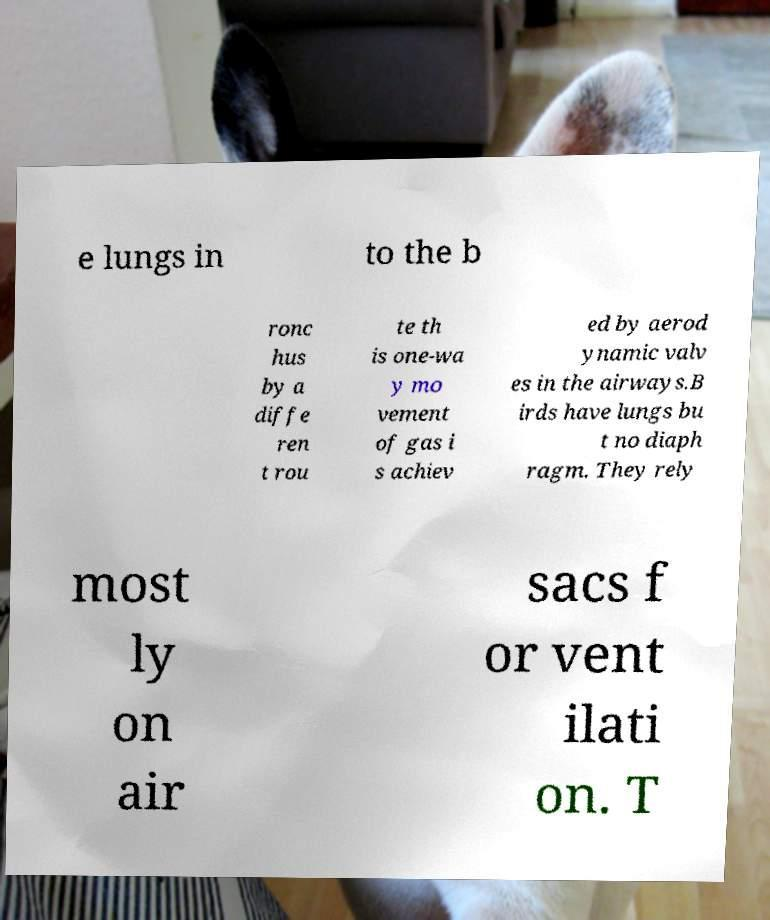Could you extract and type out the text from this image? e lungs in to the b ronc hus by a diffe ren t rou te th is one-wa y mo vement of gas i s achiev ed by aerod ynamic valv es in the airways.B irds have lungs bu t no diaph ragm. They rely most ly on air sacs f or vent ilati on. T 